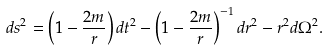<formula> <loc_0><loc_0><loc_500><loc_500>d s ^ { 2 } = \left ( 1 - \frac { 2 m } { r } \right ) d t ^ { 2 } - \left ( 1 - \frac { 2 m } { r } \right ) ^ { - 1 } d r ^ { 2 } - r ^ { 2 } d \Omega ^ { 2 } .</formula> 